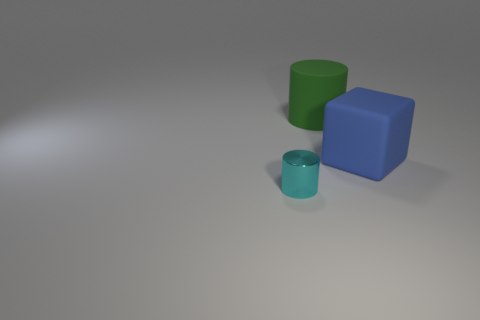Add 3 tiny cyan objects. How many objects exist? 6 Subtract 1 cubes. How many cubes are left? 0 Subtract all green cylinders. How many cylinders are left? 1 Subtract all cylinders. How many objects are left? 1 Add 1 tiny cyan cylinders. How many tiny cyan cylinders exist? 2 Subtract 0 yellow cubes. How many objects are left? 3 Subtract all red blocks. Subtract all gray spheres. How many blocks are left? 1 Subtract all big green cylinders. Subtract all large blue cubes. How many objects are left? 1 Add 3 big matte cylinders. How many big matte cylinders are left? 4 